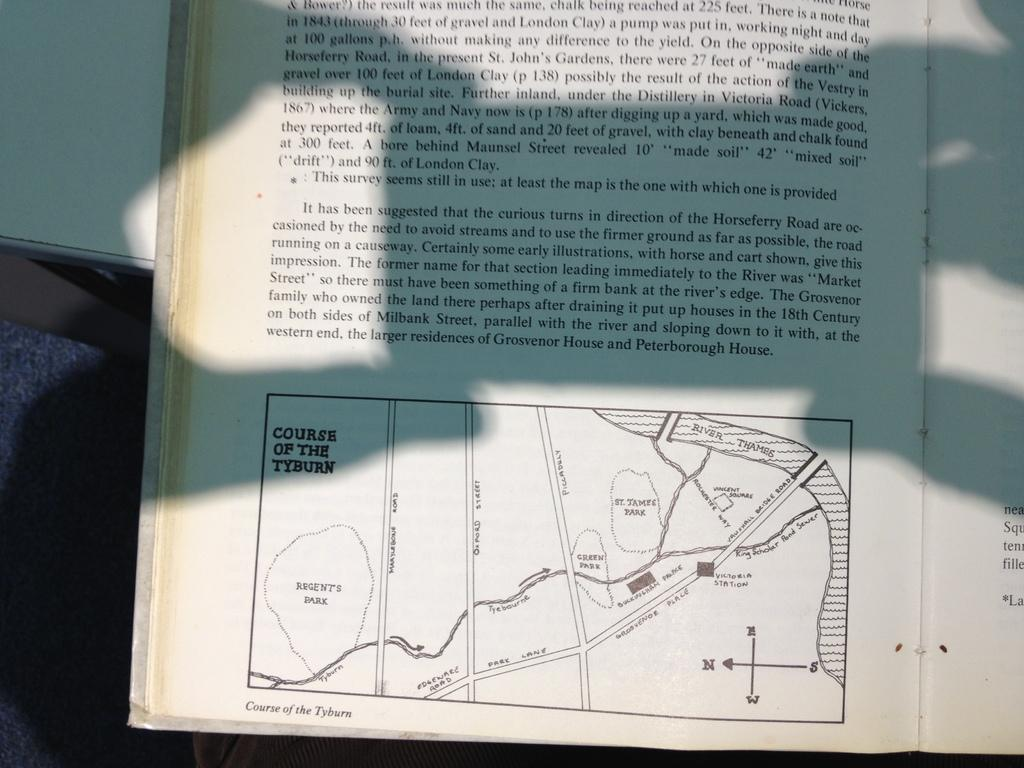<image>
Summarize the visual content of the image. A book contains a map which is named Course of the Tyburn. 